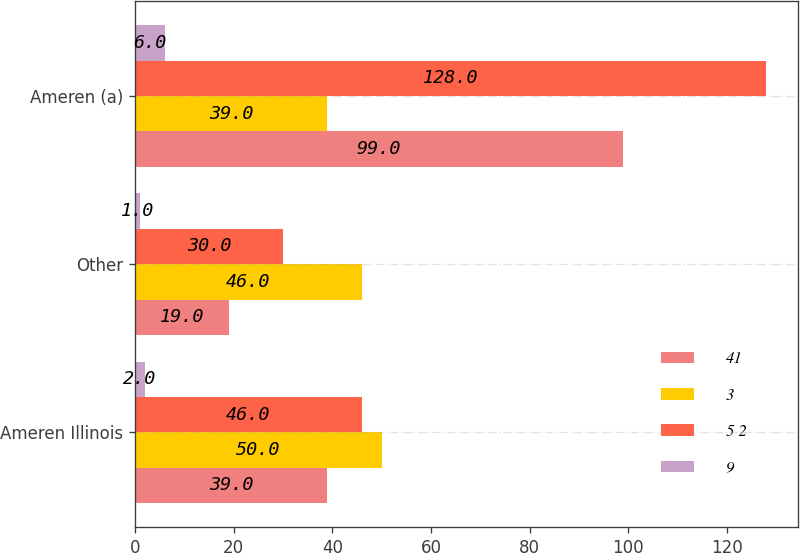Convert chart to OTSL. <chart><loc_0><loc_0><loc_500><loc_500><stacked_bar_chart><ecel><fcel>Ameren Illinois<fcel>Other<fcel>Ameren (a)<nl><fcel>41<fcel>39<fcel>19<fcel>99<nl><fcel>3<fcel>50<fcel>46<fcel>39<nl><fcel>5 2<fcel>46<fcel>30<fcel>128<nl><fcel>9<fcel>2<fcel>1<fcel>6<nl></chart> 